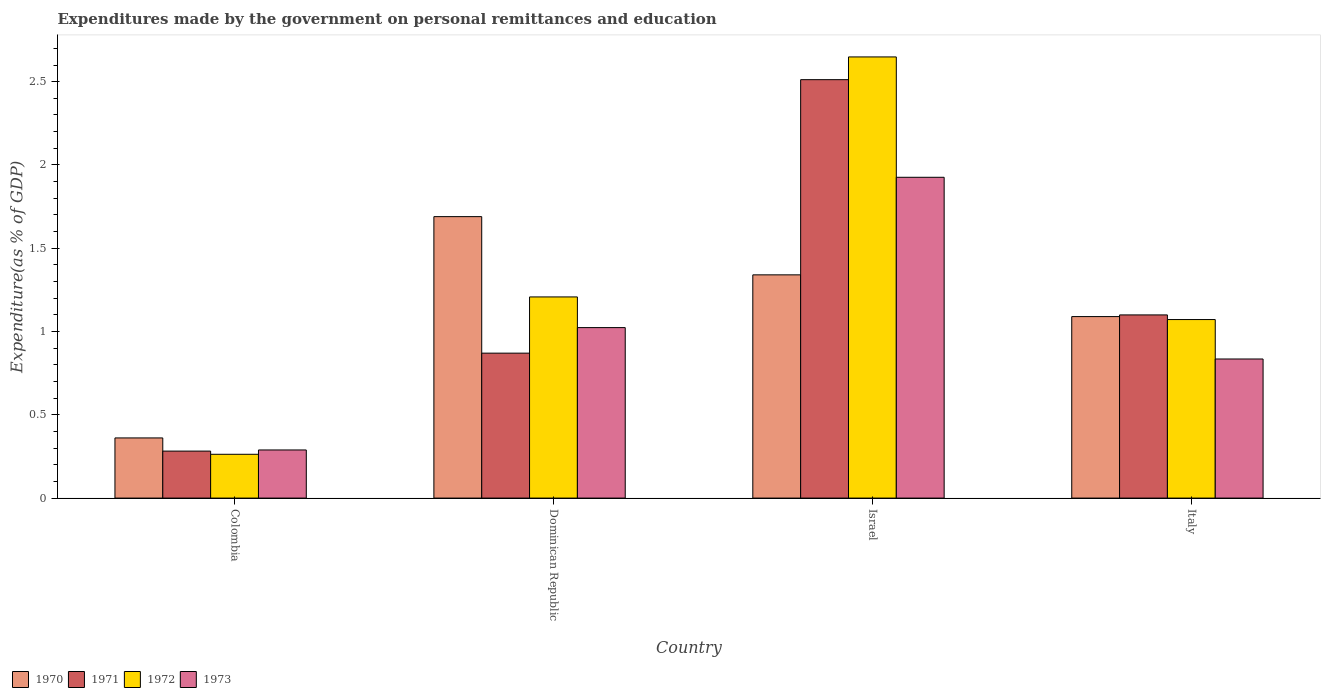How many different coloured bars are there?
Your answer should be compact. 4. Are the number of bars per tick equal to the number of legend labels?
Make the answer very short. Yes. How many bars are there on the 1st tick from the left?
Your answer should be very brief. 4. How many bars are there on the 4th tick from the right?
Make the answer very short. 4. What is the label of the 1st group of bars from the left?
Make the answer very short. Colombia. In how many cases, is the number of bars for a given country not equal to the number of legend labels?
Your answer should be compact. 0. What is the expenditures made by the government on personal remittances and education in 1972 in Colombia?
Make the answer very short. 0.26. Across all countries, what is the maximum expenditures made by the government on personal remittances and education in 1972?
Offer a very short reply. 2.65. Across all countries, what is the minimum expenditures made by the government on personal remittances and education in 1973?
Make the answer very short. 0.29. In which country was the expenditures made by the government on personal remittances and education in 1971 minimum?
Provide a succinct answer. Colombia. What is the total expenditures made by the government on personal remittances and education in 1971 in the graph?
Keep it short and to the point. 4.76. What is the difference between the expenditures made by the government on personal remittances and education in 1970 in Colombia and that in Israel?
Your answer should be compact. -0.98. What is the difference between the expenditures made by the government on personal remittances and education in 1973 in Italy and the expenditures made by the government on personal remittances and education in 1971 in Colombia?
Give a very brief answer. 0.55. What is the average expenditures made by the government on personal remittances and education in 1970 per country?
Offer a terse response. 1.12. What is the difference between the expenditures made by the government on personal remittances and education of/in 1972 and expenditures made by the government on personal remittances and education of/in 1970 in Dominican Republic?
Provide a succinct answer. -0.48. In how many countries, is the expenditures made by the government on personal remittances and education in 1971 greater than 2.5 %?
Ensure brevity in your answer.  1. What is the ratio of the expenditures made by the government on personal remittances and education in 1973 in Dominican Republic to that in Israel?
Your answer should be compact. 0.53. Is the difference between the expenditures made by the government on personal remittances and education in 1972 in Colombia and Israel greater than the difference between the expenditures made by the government on personal remittances and education in 1970 in Colombia and Israel?
Your answer should be very brief. No. What is the difference between the highest and the second highest expenditures made by the government on personal remittances and education in 1970?
Your answer should be very brief. 0.6. What is the difference between the highest and the lowest expenditures made by the government on personal remittances and education in 1970?
Keep it short and to the point. 1.33. In how many countries, is the expenditures made by the government on personal remittances and education in 1973 greater than the average expenditures made by the government on personal remittances and education in 1973 taken over all countries?
Provide a short and direct response. 2. What does the 3rd bar from the left in Italy represents?
Ensure brevity in your answer.  1972. Where does the legend appear in the graph?
Keep it short and to the point. Bottom left. How many legend labels are there?
Ensure brevity in your answer.  4. What is the title of the graph?
Give a very brief answer. Expenditures made by the government on personal remittances and education. What is the label or title of the Y-axis?
Give a very brief answer. Expenditure(as % of GDP). What is the Expenditure(as % of GDP) in 1970 in Colombia?
Your answer should be compact. 0.36. What is the Expenditure(as % of GDP) in 1971 in Colombia?
Your answer should be compact. 0.28. What is the Expenditure(as % of GDP) of 1972 in Colombia?
Ensure brevity in your answer.  0.26. What is the Expenditure(as % of GDP) of 1973 in Colombia?
Offer a terse response. 0.29. What is the Expenditure(as % of GDP) of 1970 in Dominican Republic?
Provide a short and direct response. 1.69. What is the Expenditure(as % of GDP) in 1971 in Dominican Republic?
Your answer should be very brief. 0.87. What is the Expenditure(as % of GDP) in 1972 in Dominican Republic?
Offer a terse response. 1.21. What is the Expenditure(as % of GDP) in 1973 in Dominican Republic?
Make the answer very short. 1.02. What is the Expenditure(as % of GDP) of 1970 in Israel?
Give a very brief answer. 1.34. What is the Expenditure(as % of GDP) in 1971 in Israel?
Offer a very short reply. 2.51. What is the Expenditure(as % of GDP) in 1972 in Israel?
Provide a succinct answer. 2.65. What is the Expenditure(as % of GDP) of 1973 in Israel?
Offer a very short reply. 1.93. What is the Expenditure(as % of GDP) in 1970 in Italy?
Offer a very short reply. 1.09. What is the Expenditure(as % of GDP) in 1971 in Italy?
Offer a terse response. 1.1. What is the Expenditure(as % of GDP) in 1972 in Italy?
Offer a very short reply. 1.07. What is the Expenditure(as % of GDP) in 1973 in Italy?
Provide a succinct answer. 0.84. Across all countries, what is the maximum Expenditure(as % of GDP) of 1970?
Make the answer very short. 1.69. Across all countries, what is the maximum Expenditure(as % of GDP) in 1971?
Your answer should be very brief. 2.51. Across all countries, what is the maximum Expenditure(as % of GDP) of 1972?
Your response must be concise. 2.65. Across all countries, what is the maximum Expenditure(as % of GDP) of 1973?
Give a very brief answer. 1.93. Across all countries, what is the minimum Expenditure(as % of GDP) in 1970?
Your answer should be compact. 0.36. Across all countries, what is the minimum Expenditure(as % of GDP) in 1971?
Provide a succinct answer. 0.28. Across all countries, what is the minimum Expenditure(as % of GDP) in 1972?
Give a very brief answer. 0.26. Across all countries, what is the minimum Expenditure(as % of GDP) in 1973?
Offer a very short reply. 0.29. What is the total Expenditure(as % of GDP) in 1970 in the graph?
Your answer should be very brief. 4.48. What is the total Expenditure(as % of GDP) in 1971 in the graph?
Offer a very short reply. 4.76. What is the total Expenditure(as % of GDP) of 1972 in the graph?
Give a very brief answer. 5.19. What is the total Expenditure(as % of GDP) in 1973 in the graph?
Give a very brief answer. 4.07. What is the difference between the Expenditure(as % of GDP) in 1970 in Colombia and that in Dominican Republic?
Offer a terse response. -1.33. What is the difference between the Expenditure(as % of GDP) of 1971 in Colombia and that in Dominican Republic?
Give a very brief answer. -0.59. What is the difference between the Expenditure(as % of GDP) in 1972 in Colombia and that in Dominican Republic?
Provide a short and direct response. -0.94. What is the difference between the Expenditure(as % of GDP) in 1973 in Colombia and that in Dominican Republic?
Make the answer very short. -0.73. What is the difference between the Expenditure(as % of GDP) of 1970 in Colombia and that in Israel?
Provide a succinct answer. -0.98. What is the difference between the Expenditure(as % of GDP) of 1971 in Colombia and that in Israel?
Ensure brevity in your answer.  -2.23. What is the difference between the Expenditure(as % of GDP) of 1972 in Colombia and that in Israel?
Keep it short and to the point. -2.39. What is the difference between the Expenditure(as % of GDP) in 1973 in Colombia and that in Israel?
Give a very brief answer. -1.64. What is the difference between the Expenditure(as % of GDP) of 1970 in Colombia and that in Italy?
Your answer should be compact. -0.73. What is the difference between the Expenditure(as % of GDP) of 1971 in Colombia and that in Italy?
Your answer should be very brief. -0.82. What is the difference between the Expenditure(as % of GDP) of 1972 in Colombia and that in Italy?
Make the answer very short. -0.81. What is the difference between the Expenditure(as % of GDP) in 1973 in Colombia and that in Italy?
Your response must be concise. -0.55. What is the difference between the Expenditure(as % of GDP) of 1970 in Dominican Republic and that in Israel?
Offer a terse response. 0.35. What is the difference between the Expenditure(as % of GDP) of 1971 in Dominican Republic and that in Israel?
Provide a succinct answer. -1.64. What is the difference between the Expenditure(as % of GDP) in 1972 in Dominican Republic and that in Israel?
Give a very brief answer. -1.44. What is the difference between the Expenditure(as % of GDP) in 1973 in Dominican Republic and that in Israel?
Make the answer very short. -0.9. What is the difference between the Expenditure(as % of GDP) in 1970 in Dominican Republic and that in Italy?
Provide a short and direct response. 0.6. What is the difference between the Expenditure(as % of GDP) in 1971 in Dominican Republic and that in Italy?
Ensure brevity in your answer.  -0.23. What is the difference between the Expenditure(as % of GDP) of 1972 in Dominican Republic and that in Italy?
Offer a very short reply. 0.14. What is the difference between the Expenditure(as % of GDP) in 1973 in Dominican Republic and that in Italy?
Your answer should be very brief. 0.19. What is the difference between the Expenditure(as % of GDP) in 1970 in Israel and that in Italy?
Provide a succinct answer. 0.25. What is the difference between the Expenditure(as % of GDP) of 1971 in Israel and that in Italy?
Offer a very short reply. 1.41. What is the difference between the Expenditure(as % of GDP) in 1972 in Israel and that in Italy?
Ensure brevity in your answer.  1.58. What is the difference between the Expenditure(as % of GDP) in 1973 in Israel and that in Italy?
Ensure brevity in your answer.  1.09. What is the difference between the Expenditure(as % of GDP) in 1970 in Colombia and the Expenditure(as % of GDP) in 1971 in Dominican Republic?
Offer a very short reply. -0.51. What is the difference between the Expenditure(as % of GDP) of 1970 in Colombia and the Expenditure(as % of GDP) of 1972 in Dominican Republic?
Your response must be concise. -0.85. What is the difference between the Expenditure(as % of GDP) of 1970 in Colombia and the Expenditure(as % of GDP) of 1973 in Dominican Republic?
Provide a succinct answer. -0.66. What is the difference between the Expenditure(as % of GDP) in 1971 in Colombia and the Expenditure(as % of GDP) in 1972 in Dominican Republic?
Keep it short and to the point. -0.93. What is the difference between the Expenditure(as % of GDP) in 1971 in Colombia and the Expenditure(as % of GDP) in 1973 in Dominican Republic?
Give a very brief answer. -0.74. What is the difference between the Expenditure(as % of GDP) in 1972 in Colombia and the Expenditure(as % of GDP) in 1973 in Dominican Republic?
Your answer should be compact. -0.76. What is the difference between the Expenditure(as % of GDP) of 1970 in Colombia and the Expenditure(as % of GDP) of 1971 in Israel?
Make the answer very short. -2.15. What is the difference between the Expenditure(as % of GDP) in 1970 in Colombia and the Expenditure(as % of GDP) in 1972 in Israel?
Provide a short and direct response. -2.29. What is the difference between the Expenditure(as % of GDP) of 1970 in Colombia and the Expenditure(as % of GDP) of 1973 in Israel?
Keep it short and to the point. -1.56. What is the difference between the Expenditure(as % of GDP) of 1971 in Colombia and the Expenditure(as % of GDP) of 1972 in Israel?
Make the answer very short. -2.37. What is the difference between the Expenditure(as % of GDP) in 1971 in Colombia and the Expenditure(as % of GDP) in 1973 in Israel?
Provide a short and direct response. -1.64. What is the difference between the Expenditure(as % of GDP) of 1972 in Colombia and the Expenditure(as % of GDP) of 1973 in Israel?
Provide a succinct answer. -1.66. What is the difference between the Expenditure(as % of GDP) in 1970 in Colombia and the Expenditure(as % of GDP) in 1971 in Italy?
Give a very brief answer. -0.74. What is the difference between the Expenditure(as % of GDP) in 1970 in Colombia and the Expenditure(as % of GDP) in 1972 in Italy?
Ensure brevity in your answer.  -0.71. What is the difference between the Expenditure(as % of GDP) in 1970 in Colombia and the Expenditure(as % of GDP) in 1973 in Italy?
Your response must be concise. -0.47. What is the difference between the Expenditure(as % of GDP) of 1971 in Colombia and the Expenditure(as % of GDP) of 1972 in Italy?
Your answer should be very brief. -0.79. What is the difference between the Expenditure(as % of GDP) of 1971 in Colombia and the Expenditure(as % of GDP) of 1973 in Italy?
Offer a terse response. -0.55. What is the difference between the Expenditure(as % of GDP) in 1972 in Colombia and the Expenditure(as % of GDP) in 1973 in Italy?
Your response must be concise. -0.57. What is the difference between the Expenditure(as % of GDP) of 1970 in Dominican Republic and the Expenditure(as % of GDP) of 1971 in Israel?
Keep it short and to the point. -0.82. What is the difference between the Expenditure(as % of GDP) of 1970 in Dominican Republic and the Expenditure(as % of GDP) of 1972 in Israel?
Your answer should be compact. -0.96. What is the difference between the Expenditure(as % of GDP) in 1970 in Dominican Republic and the Expenditure(as % of GDP) in 1973 in Israel?
Ensure brevity in your answer.  -0.24. What is the difference between the Expenditure(as % of GDP) in 1971 in Dominican Republic and the Expenditure(as % of GDP) in 1972 in Israel?
Your response must be concise. -1.78. What is the difference between the Expenditure(as % of GDP) in 1971 in Dominican Republic and the Expenditure(as % of GDP) in 1973 in Israel?
Your response must be concise. -1.06. What is the difference between the Expenditure(as % of GDP) of 1972 in Dominican Republic and the Expenditure(as % of GDP) of 1973 in Israel?
Provide a succinct answer. -0.72. What is the difference between the Expenditure(as % of GDP) in 1970 in Dominican Republic and the Expenditure(as % of GDP) in 1971 in Italy?
Your answer should be compact. 0.59. What is the difference between the Expenditure(as % of GDP) in 1970 in Dominican Republic and the Expenditure(as % of GDP) in 1972 in Italy?
Offer a very short reply. 0.62. What is the difference between the Expenditure(as % of GDP) in 1970 in Dominican Republic and the Expenditure(as % of GDP) in 1973 in Italy?
Offer a very short reply. 0.85. What is the difference between the Expenditure(as % of GDP) of 1971 in Dominican Republic and the Expenditure(as % of GDP) of 1972 in Italy?
Keep it short and to the point. -0.2. What is the difference between the Expenditure(as % of GDP) in 1971 in Dominican Republic and the Expenditure(as % of GDP) in 1973 in Italy?
Provide a succinct answer. 0.04. What is the difference between the Expenditure(as % of GDP) of 1972 in Dominican Republic and the Expenditure(as % of GDP) of 1973 in Italy?
Offer a terse response. 0.37. What is the difference between the Expenditure(as % of GDP) in 1970 in Israel and the Expenditure(as % of GDP) in 1971 in Italy?
Ensure brevity in your answer.  0.24. What is the difference between the Expenditure(as % of GDP) in 1970 in Israel and the Expenditure(as % of GDP) in 1972 in Italy?
Offer a very short reply. 0.27. What is the difference between the Expenditure(as % of GDP) of 1970 in Israel and the Expenditure(as % of GDP) of 1973 in Italy?
Your answer should be very brief. 0.51. What is the difference between the Expenditure(as % of GDP) of 1971 in Israel and the Expenditure(as % of GDP) of 1972 in Italy?
Your response must be concise. 1.44. What is the difference between the Expenditure(as % of GDP) in 1971 in Israel and the Expenditure(as % of GDP) in 1973 in Italy?
Provide a succinct answer. 1.68. What is the difference between the Expenditure(as % of GDP) of 1972 in Israel and the Expenditure(as % of GDP) of 1973 in Italy?
Your answer should be very brief. 1.81. What is the average Expenditure(as % of GDP) in 1970 per country?
Provide a short and direct response. 1.12. What is the average Expenditure(as % of GDP) of 1971 per country?
Keep it short and to the point. 1.19. What is the average Expenditure(as % of GDP) in 1972 per country?
Your response must be concise. 1.3. What is the average Expenditure(as % of GDP) of 1973 per country?
Your answer should be compact. 1.02. What is the difference between the Expenditure(as % of GDP) of 1970 and Expenditure(as % of GDP) of 1971 in Colombia?
Provide a short and direct response. 0.08. What is the difference between the Expenditure(as % of GDP) in 1970 and Expenditure(as % of GDP) in 1972 in Colombia?
Offer a very short reply. 0.1. What is the difference between the Expenditure(as % of GDP) in 1970 and Expenditure(as % of GDP) in 1973 in Colombia?
Your answer should be compact. 0.07. What is the difference between the Expenditure(as % of GDP) in 1971 and Expenditure(as % of GDP) in 1972 in Colombia?
Your response must be concise. 0.02. What is the difference between the Expenditure(as % of GDP) in 1971 and Expenditure(as % of GDP) in 1973 in Colombia?
Keep it short and to the point. -0.01. What is the difference between the Expenditure(as % of GDP) in 1972 and Expenditure(as % of GDP) in 1973 in Colombia?
Provide a succinct answer. -0.03. What is the difference between the Expenditure(as % of GDP) in 1970 and Expenditure(as % of GDP) in 1971 in Dominican Republic?
Ensure brevity in your answer.  0.82. What is the difference between the Expenditure(as % of GDP) in 1970 and Expenditure(as % of GDP) in 1972 in Dominican Republic?
Make the answer very short. 0.48. What is the difference between the Expenditure(as % of GDP) in 1970 and Expenditure(as % of GDP) in 1973 in Dominican Republic?
Keep it short and to the point. 0.67. What is the difference between the Expenditure(as % of GDP) of 1971 and Expenditure(as % of GDP) of 1972 in Dominican Republic?
Provide a succinct answer. -0.34. What is the difference between the Expenditure(as % of GDP) of 1971 and Expenditure(as % of GDP) of 1973 in Dominican Republic?
Provide a short and direct response. -0.15. What is the difference between the Expenditure(as % of GDP) of 1972 and Expenditure(as % of GDP) of 1973 in Dominican Republic?
Make the answer very short. 0.18. What is the difference between the Expenditure(as % of GDP) in 1970 and Expenditure(as % of GDP) in 1971 in Israel?
Offer a terse response. -1.17. What is the difference between the Expenditure(as % of GDP) in 1970 and Expenditure(as % of GDP) in 1972 in Israel?
Make the answer very short. -1.31. What is the difference between the Expenditure(as % of GDP) in 1970 and Expenditure(as % of GDP) in 1973 in Israel?
Give a very brief answer. -0.59. What is the difference between the Expenditure(as % of GDP) in 1971 and Expenditure(as % of GDP) in 1972 in Israel?
Ensure brevity in your answer.  -0.14. What is the difference between the Expenditure(as % of GDP) in 1971 and Expenditure(as % of GDP) in 1973 in Israel?
Ensure brevity in your answer.  0.59. What is the difference between the Expenditure(as % of GDP) of 1972 and Expenditure(as % of GDP) of 1973 in Israel?
Your response must be concise. 0.72. What is the difference between the Expenditure(as % of GDP) in 1970 and Expenditure(as % of GDP) in 1971 in Italy?
Give a very brief answer. -0.01. What is the difference between the Expenditure(as % of GDP) of 1970 and Expenditure(as % of GDP) of 1972 in Italy?
Your answer should be compact. 0.02. What is the difference between the Expenditure(as % of GDP) of 1970 and Expenditure(as % of GDP) of 1973 in Italy?
Give a very brief answer. 0.25. What is the difference between the Expenditure(as % of GDP) in 1971 and Expenditure(as % of GDP) in 1972 in Italy?
Give a very brief answer. 0.03. What is the difference between the Expenditure(as % of GDP) of 1971 and Expenditure(as % of GDP) of 1973 in Italy?
Offer a very short reply. 0.26. What is the difference between the Expenditure(as % of GDP) of 1972 and Expenditure(as % of GDP) of 1973 in Italy?
Ensure brevity in your answer.  0.24. What is the ratio of the Expenditure(as % of GDP) of 1970 in Colombia to that in Dominican Republic?
Provide a short and direct response. 0.21. What is the ratio of the Expenditure(as % of GDP) of 1971 in Colombia to that in Dominican Republic?
Provide a succinct answer. 0.32. What is the ratio of the Expenditure(as % of GDP) in 1972 in Colombia to that in Dominican Republic?
Make the answer very short. 0.22. What is the ratio of the Expenditure(as % of GDP) of 1973 in Colombia to that in Dominican Republic?
Provide a short and direct response. 0.28. What is the ratio of the Expenditure(as % of GDP) in 1970 in Colombia to that in Israel?
Your answer should be very brief. 0.27. What is the ratio of the Expenditure(as % of GDP) in 1971 in Colombia to that in Israel?
Keep it short and to the point. 0.11. What is the ratio of the Expenditure(as % of GDP) in 1972 in Colombia to that in Israel?
Give a very brief answer. 0.1. What is the ratio of the Expenditure(as % of GDP) of 1973 in Colombia to that in Israel?
Provide a succinct answer. 0.15. What is the ratio of the Expenditure(as % of GDP) of 1970 in Colombia to that in Italy?
Your answer should be very brief. 0.33. What is the ratio of the Expenditure(as % of GDP) of 1971 in Colombia to that in Italy?
Make the answer very short. 0.26. What is the ratio of the Expenditure(as % of GDP) of 1972 in Colombia to that in Italy?
Your response must be concise. 0.25. What is the ratio of the Expenditure(as % of GDP) in 1973 in Colombia to that in Italy?
Ensure brevity in your answer.  0.35. What is the ratio of the Expenditure(as % of GDP) in 1970 in Dominican Republic to that in Israel?
Offer a terse response. 1.26. What is the ratio of the Expenditure(as % of GDP) of 1971 in Dominican Republic to that in Israel?
Your answer should be very brief. 0.35. What is the ratio of the Expenditure(as % of GDP) in 1972 in Dominican Republic to that in Israel?
Your answer should be compact. 0.46. What is the ratio of the Expenditure(as % of GDP) of 1973 in Dominican Republic to that in Israel?
Keep it short and to the point. 0.53. What is the ratio of the Expenditure(as % of GDP) in 1970 in Dominican Republic to that in Italy?
Your response must be concise. 1.55. What is the ratio of the Expenditure(as % of GDP) of 1971 in Dominican Republic to that in Italy?
Make the answer very short. 0.79. What is the ratio of the Expenditure(as % of GDP) of 1972 in Dominican Republic to that in Italy?
Your response must be concise. 1.13. What is the ratio of the Expenditure(as % of GDP) in 1973 in Dominican Republic to that in Italy?
Give a very brief answer. 1.23. What is the ratio of the Expenditure(as % of GDP) of 1970 in Israel to that in Italy?
Your response must be concise. 1.23. What is the ratio of the Expenditure(as % of GDP) in 1971 in Israel to that in Italy?
Your answer should be compact. 2.28. What is the ratio of the Expenditure(as % of GDP) in 1972 in Israel to that in Italy?
Your answer should be very brief. 2.47. What is the ratio of the Expenditure(as % of GDP) of 1973 in Israel to that in Italy?
Give a very brief answer. 2.31. What is the difference between the highest and the second highest Expenditure(as % of GDP) of 1970?
Your answer should be very brief. 0.35. What is the difference between the highest and the second highest Expenditure(as % of GDP) of 1971?
Your answer should be very brief. 1.41. What is the difference between the highest and the second highest Expenditure(as % of GDP) in 1972?
Provide a succinct answer. 1.44. What is the difference between the highest and the second highest Expenditure(as % of GDP) in 1973?
Provide a short and direct response. 0.9. What is the difference between the highest and the lowest Expenditure(as % of GDP) of 1970?
Provide a succinct answer. 1.33. What is the difference between the highest and the lowest Expenditure(as % of GDP) of 1971?
Your response must be concise. 2.23. What is the difference between the highest and the lowest Expenditure(as % of GDP) of 1972?
Offer a very short reply. 2.39. What is the difference between the highest and the lowest Expenditure(as % of GDP) of 1973?
Keep it short and to the point. 1.64. 